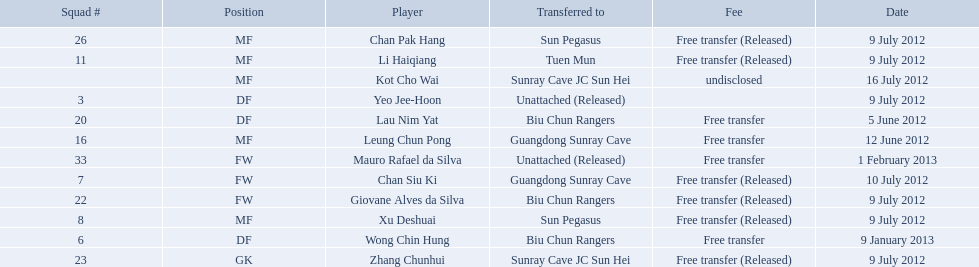Which players played during the 2012-13 south china aa season? Lau Nim Yat, Leung Chun Pong, Yeo Jee-Hoon, Xu Deshuai, Li Haiqiang, Giovane Alves da Silva, Zhang Chunhui, Chan Pak Hang, Chan Siu Ki, Kot Cho Wai, Wong Chin Hung, Mauro Rafael da Silva. Of these, which were free transfers that were not released? Lau Nim Yat, Leung Chun Pong, Wong Chin Hung, Mauro Rafael da Silva. Of these, which were in squad # 6? Wong Chin Hung. What was the date of his transfer? 9 January 2013. 